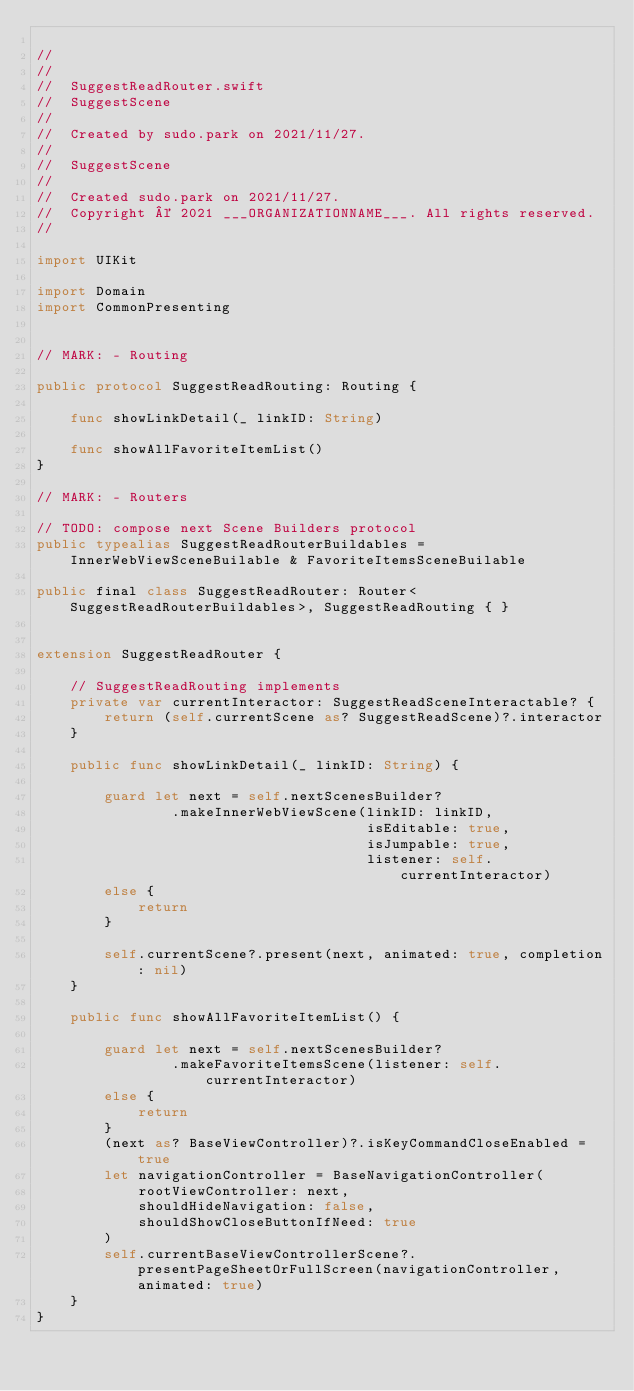<code> <loc_0><loc_0><loc_500><loc_500><_Swift_>
//
//  
//  SuggestReadRouter.swift
//  SuggestScene
//
//  Created by sudo.park on 2021/11/27.
//
//  SuggestScene
//
//  Created sudo.park on 2021/11/27.
//  Copyright © 2021 ___ORGANIZATIONNAME___. All rights reserved.
//

import UIKit

import Domain
import CommonPresenting


// MARK: - Routing

public protocol SuggestReadRouting: Routing { 
    
    func showLinkDetail(_ linkID: String)
    
    func showAllFavoriteItemList()
}

// MARK: - Routers

// TODO: compose next Scene Builders protocol
public typealias SuggestReadRouterBuildables = InnerWebViewSceneBuilable & FavoriteItemsSceneBuilable

public final class SuggestReadRouter: Router<SuggestReadRouterBuildables>, SuggestReadRouting { }


extension SuggestReadRouter {
    
    // SuggestReadRouting implements
    private var currentInteractor: SuggestReadSceneInteractable? {
        return (self.currentScene as? SuggestReadScene)?.interactor
    }
    
    public func showLinkDetail(_ linkID: String) {
        
        guard let next = self.nextScenesBuilder?
                .makeInnerWebViewScene(linkID: linkID,
                                       isEditable: true,
                                       isJumpable: true,
                                       listener: self.currentInteractor)
        else {
            return
        }
        
        self.currentScene?.present(next, animated: true, completion: nil)
    }
    
    public func showAllFavoriteItemList() {
        
        guard let next = self.nextScenesBuilder?
                .makeFavoriteItemsScene(listener: self.currentInteractor)
        else {
            return
        }
        (next as? BaseViewController)?.isKeyCommandCloseEnabled = true
        let navigationController = BaseNavigationController(
            rootViewController: next,
            shouldHideNavigation: false,
            shouldShowCloseButtonIfNeed: true
        )
        self.currentBaseViewControllerScene?.presentPageSheetOrFullScreen(navigationController, animated: true)
    }
}
</code> 